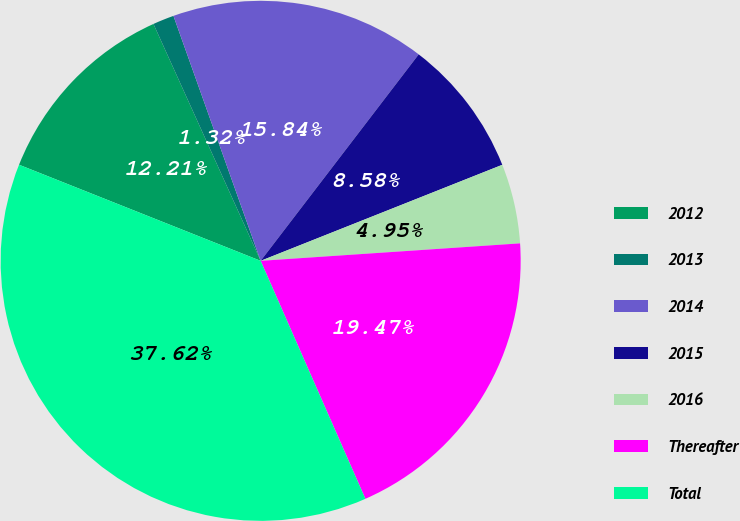Convert chart. <chart><loc_0><loc_0><loc_500><loc_500><pie_chart><fcel>2012<fcel>2013<fcel>2014<fcel>2015<fcel>2016<fcel>Thereafter<fcel>Total<nl><fcel>12.21%<fcel>1.32%<fcel>15.84%<fcel>8.58%<fcel>4.95%<fcel>19.47%<fcel>37.62%<nl></chart> 